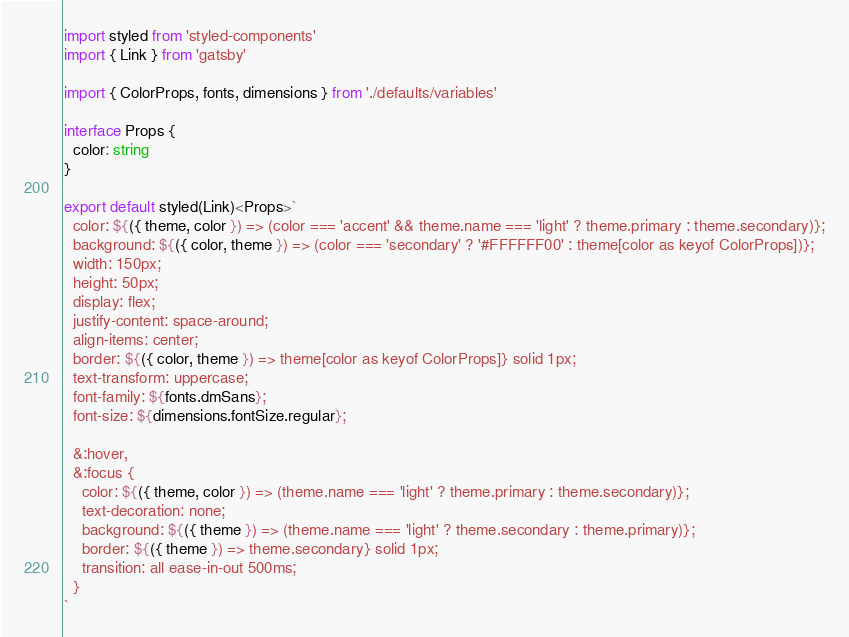<code> <loc_0><loc_0><loc_500><loc_500><_TypeScript_>import styled from 'styled-components'
import { Link } from 'gatsby'

import { ColorProps, fonts, dimensions } from './defaults/variables'

interface Props {
  color: string
}

export default styled(Link)<Props>`
  color: ${({ theme, color }) => (color === 'accent' && theme.name === 'light' ? theme.primary : theme.secondary)};
  background: ${({ color, theme }) => (color === 'secondary' ? '#FFFFFF00' : theme[color as keyof ColorProps])};
  width: 150px;
  height: 50px;
  display: flex;
  justify-content: space-around;
  align-items: center;
  border: ${({ color, theme }) => theme[color as keyof ColorProps]} solid 1px;
  text-transform: uppercase;
  font-family: ${fonts.dmSans};
  font-size: ${dimensions.fontSize.regular};

  &:hover,
  &:focus {
    color: ${({ theme, color }) => (theme.name === 'light' ? theme.primary : theme.secondary)};
    text-decoration: none;
    background: ${({ theme }) => (theme.name === 'light' ? theme.secondary : theme.primary)};
    border: ${({ theme }) => theme.secondary} solid 1px;
    transition: all ease-in-out 500ms;
  }
`
</code> 